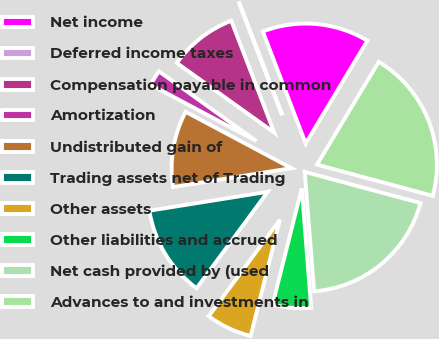Convert chart to OTSL. <chart><loc_0><loc_0><loc_500><loc_500><pie_chart><fcel>Net income<fcel>Deferred income taxes<fcel>Compensation payable in common<fcel>Amortization<fcel>Undistributed gain of<fcel>Trading assets net of Trading<fcel>Other assets<fcel>Other liabilities and accrued<fcel>Net cash provided by (used<fcel>Advances to and investments in<nl><fcel>14.42%<fcel>0.03%<fcel>9.28%<fcel>2.09%<fcel>10.31%<fcel>12.36%<fcel>6.2%<fcel>5.17%<fcel>19.56%<fcel>20.59%<nl></chart> 